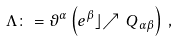Convert formula to latex. <formula><loc_0><loc_0><loc_500><loc_500>\Lambda \colon = \vartheta ^ { \alpha } \left ( e ^ { \beta } \rfloor { \nearrow \, Q } _ { \alpha \beta } \right ) \, ,</formula> 